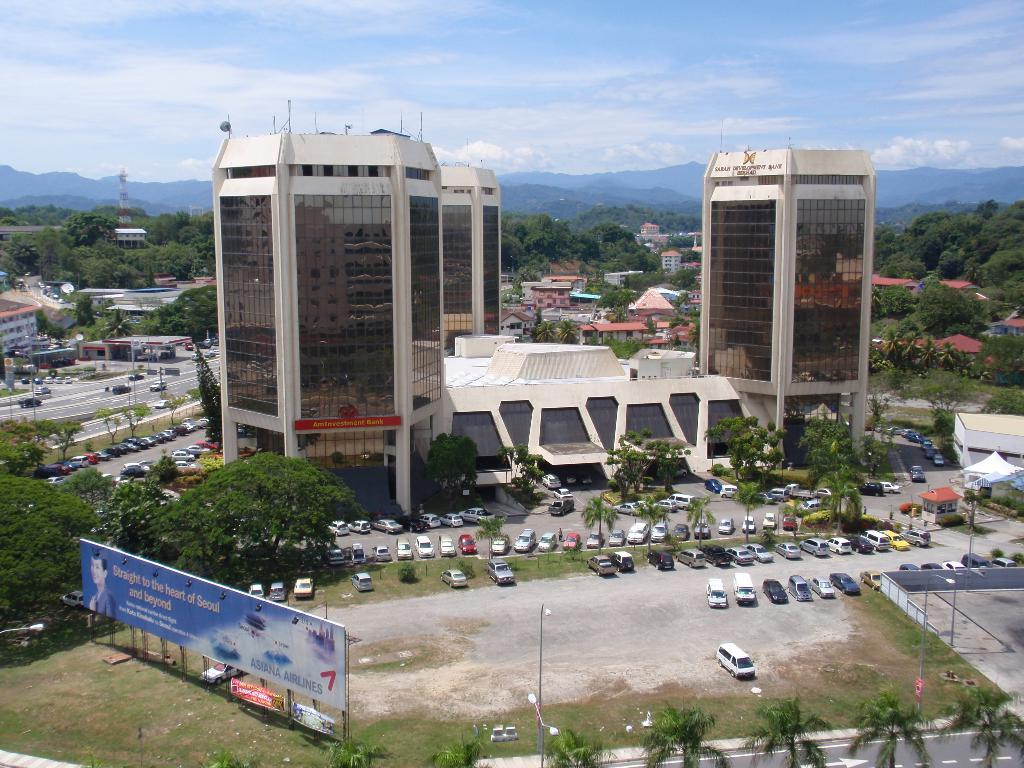What type of structures can be seen in the image? There are buildings in the image. What other natural elements are present in the image? There are trees in the image. Are there any vehicles visible in the image? Yes, there are cars in the image. What is the content of the advertisement board in the image? There is an advertisement board with text in the image. What can be seen in the distance in the background of the image? There are mountains in the background of the image. What is the condition of the sky in the background of the image? The sky is visible in the background of the image, and there are clouds present. How many frogs are sitting on the advertisement board in the image? There are no frogs present in the image, and therefore no such activity can be observed. What type of paper is being used to cover the mountains in the image? There is no paper covering the mountains in the image; they are visible in the background. 